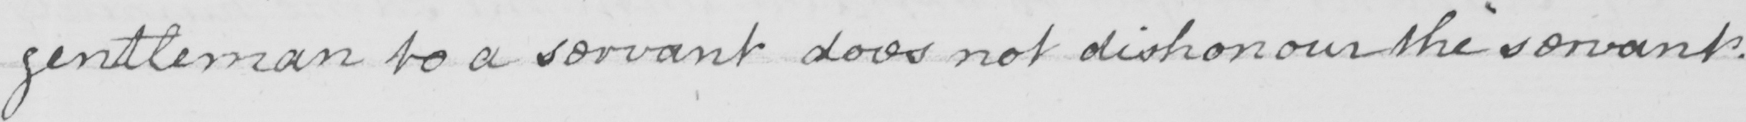What does this handwritten line say? gentleman to a servant does not dishonour the servant . 